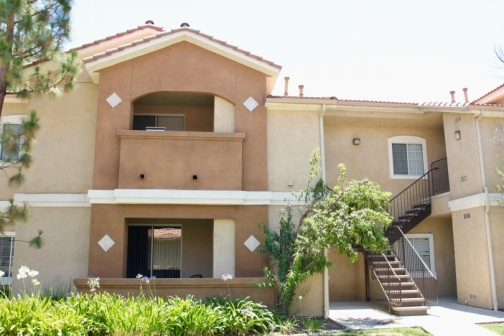What do you see happening in this image? The image depicts a tranquil residential scene centered around a two-story apartment building. The structure is painted in soft beige tones with a charming terra cotta roof. On the second floor, there is a balcony that looks ideal for enjoying the view, while the first floor features a shaded patio. The building is surrounded by lush greenery, including a prominent pine tree and various shrubs, contributing to a serene setting. The well-maintained lawn adds to the peaceful ambiance of the environment. The overall atmosphere is one of quiet suburban life, with no people present in the image, enhancing the sense of calm and solitude. 